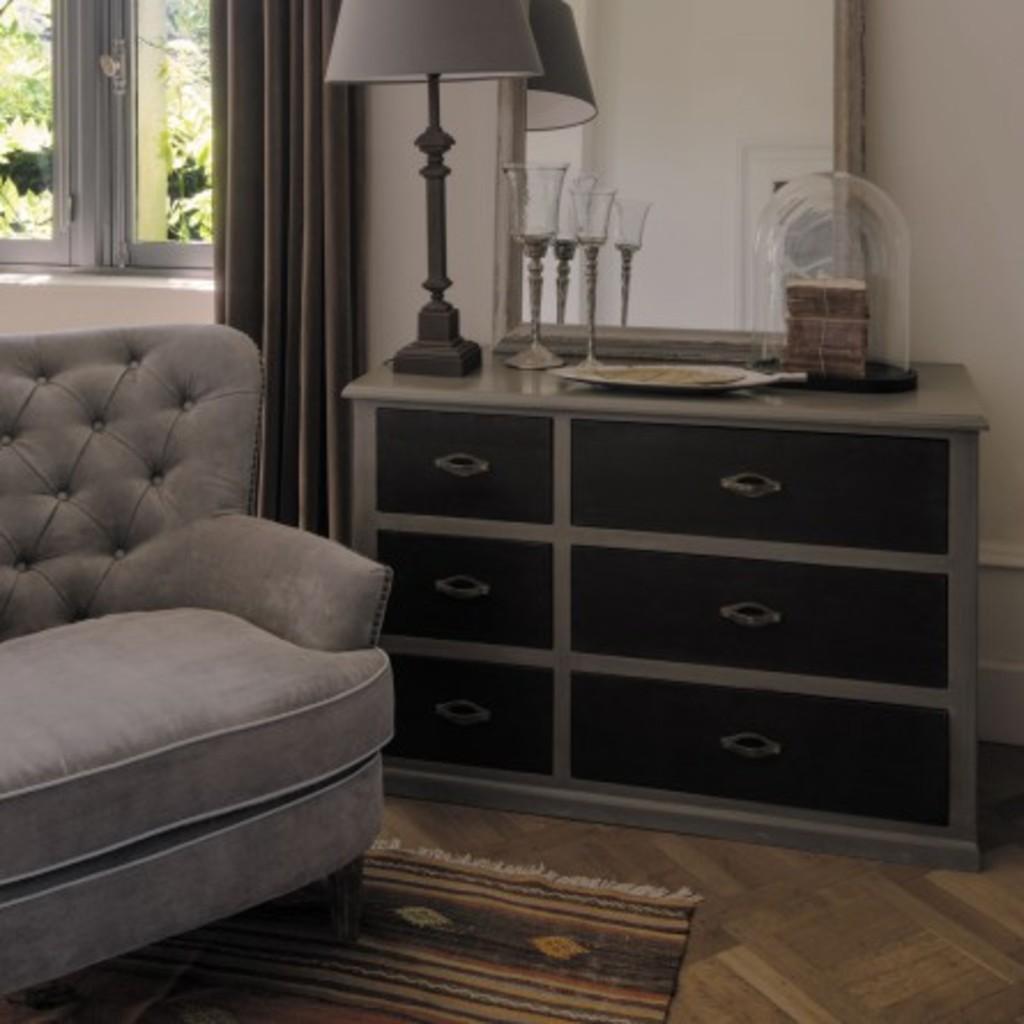Describe this image in one or two sentences. In the image in the center we can see one couch,carpet,table and drawers. On the table,we can see glasses,lamp,mirror,jar,plate and some food items. In the background there is a wall,curtain and window. 